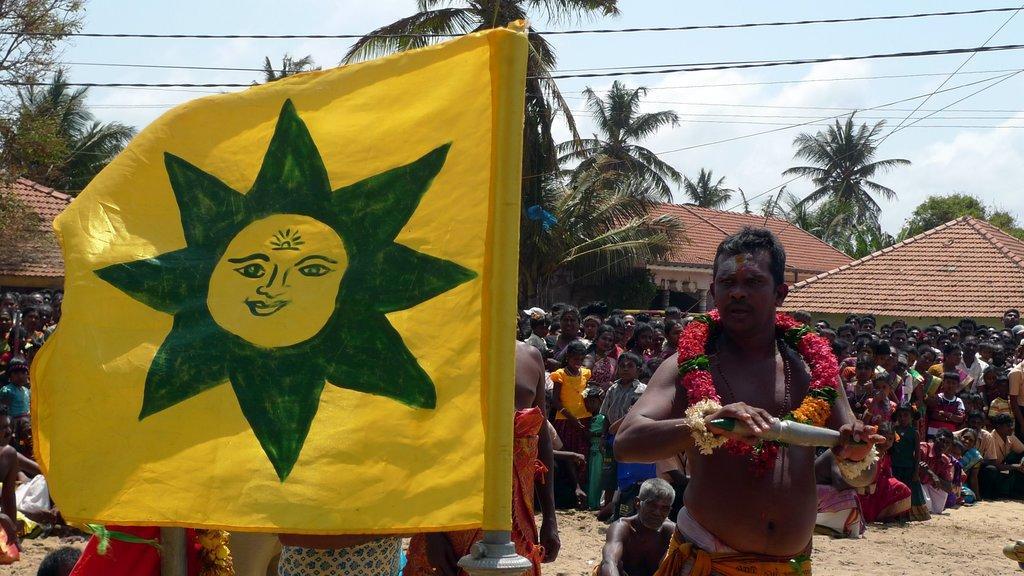Could you give a brief overview of what you see in this image? In this image there are group of people standing and some of them are sitting, in the foreground there is one flag pole and one person is wearing a garland and holding something in his hands. At the bottom there is sand, in the background there are some trees, houses, wires. At the top of the image there is sky. 